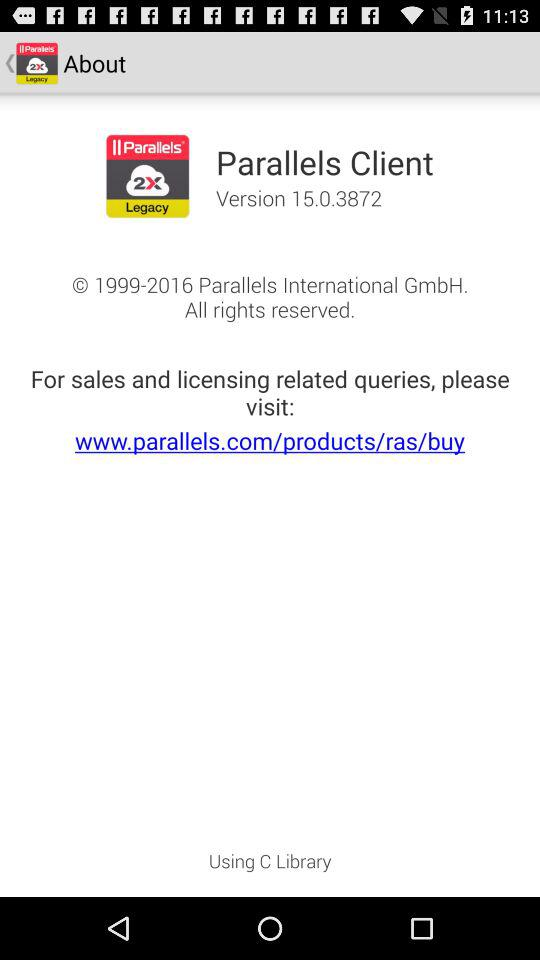Who is the copyright owner? The copyright owner is Parallels International GmbH. 